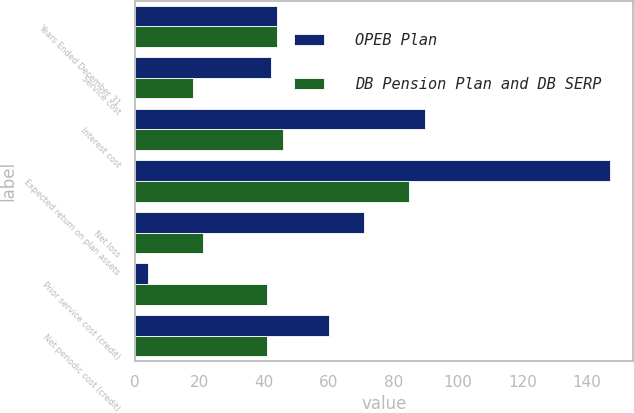Convert chart. <chart><loc_0><loc_0><loc_500><loc_500><stacked_bar_chart><ecel><fcel>Years Ended December 31<fcel>Service cost<fcel>Interest cost<fcel>Expected return on plan assets<fcel>Net loss<fcel>Prior service cost (credit)<fcel>Net periodic cost (credit)<nl><fcel>OPEB Plan<fcel>44<fcel>42<fcel>90<fcel>147<fcel>71<fcel>4<fcel>60<nl><fcel>DB Pension Plan and DB SERP<fcel>44<fcel>18<fcel>46<fcel>85<fcel>21<fcel>41<fcel>41<nl></chart> 